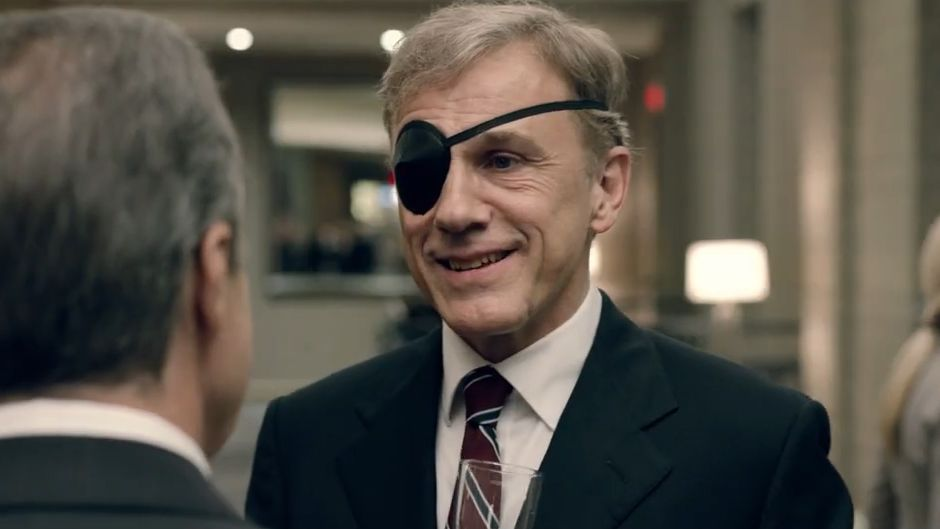Can you describe the setting and speculate about the event they are attending? The setting appears to be a well-appointed office or luxurious lobby, indicative of a formal or high-profile environment. The blurred background highlights ambient lighting, sleek furnishings, and a few people who seem to be engaged in conversations of their own. This suggests that the event could be a high-profile business meeting, a networking event, or even a formal reception. Given Christoph Waltz's elegant attire and the sophisticated surroundings, it's plausible that this is an exclusive gathering, perhaps celebrating a significant milestone, a film premiere, or a formal business summit. 